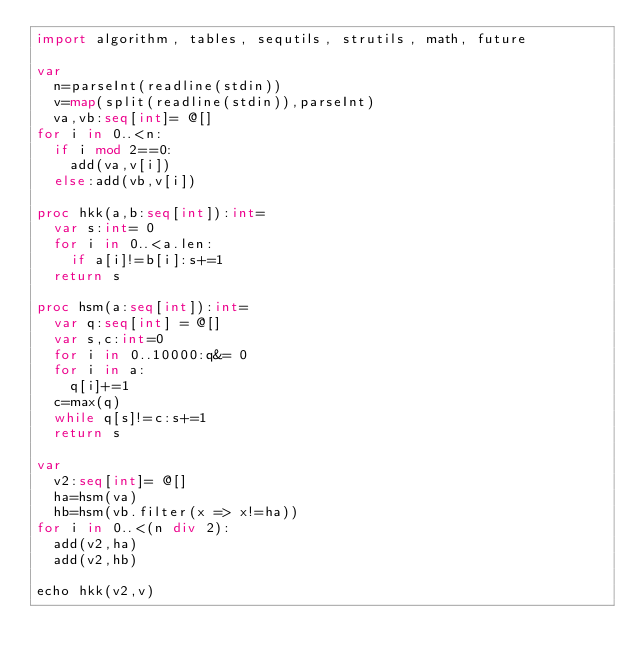Convert code to text. <code><loc_0><loc_0><loc_500><loc_500><_Nim_>import algorithm, tables, sequtils, strutils, math, future

var
  n=parseInt(readline(stdin))
  v=map(split(readline(stdin)),parseInt)
  va,vb:seq[int]= @[]
for i in 0..<n:
  if i mod 2==0:
    add(va,v[i])
  else:add(vb,v[i])

proc hkk(a,b:seq[int]):int=
  var s:int= 0
  for i in 0..<a.len:
    if a[i]!=b[i]:s+=1
  return s

proc hsm(a:seq[int]):int=
  var q:seq[int] = @[]
  var s,c:int=0
  for i in 0..10000:q&= 0
  for i in a:
    q[i]+=1
  c=max(q)
  while q[s]!=c:s+=1
  return s

var
  v2:seq[int]= @[]
  ha=hsm(va)
  hb=hsm(vb.filter(x => x!=ha))
for i in 0..<(n div 2):
  add(v2,ha)
  add(v2,hb)

echo hkk(v2,v)


</code> 